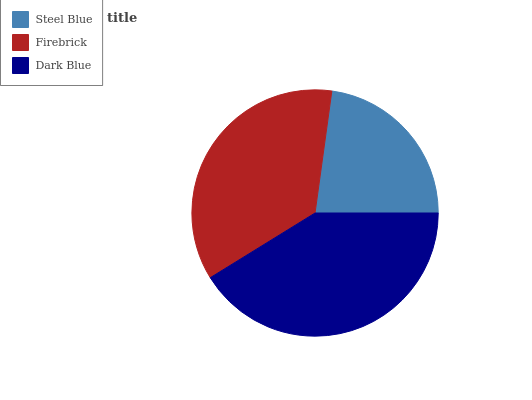Is Steel Blue the minimum?
Answer yes or no. Yes. Is Dark Blue the maximum?
Answer yes or no. Yes. Is Firebrick the minimum?
Answer yes or no. No. Is Firebrick the maximum?
Answer yes or no. No. Is Firebrick greater than Steel Blue?
Answer yes or no. Yes. Is Steel Blue less than Firebrick?
Answer yes or no. Yes. Is Steel Blue greater than Firebrick?
Answer yes or no. No. Is Firebrick less than Steel Blue?
Answer yes or no. No. Is Firebrick the high median?
Answer yes or no. Yes. Is Firebrick the low median?
Answer yes or no. Yes. Is Dark Blue the high median?
Answer yes or no. No. Is Steel Blue the low median?
Answer yes or no. No. 